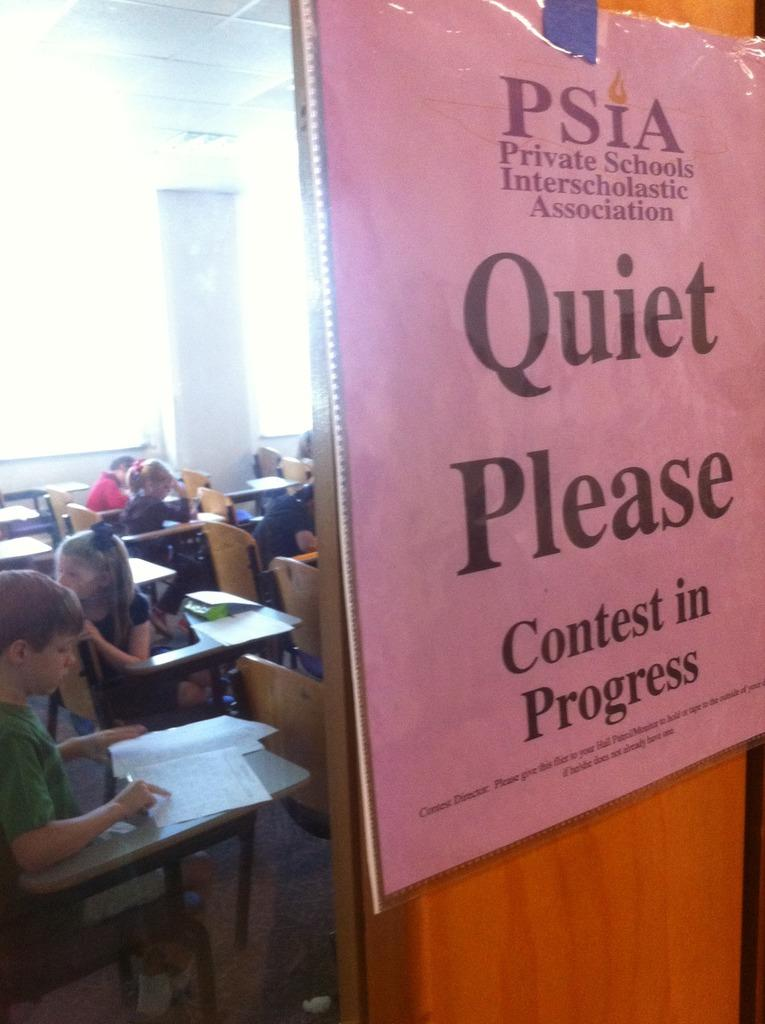<image>
Share a concise interpretation of the image provided. Several children are in a classroom with a closed door that has a pink piece of paper on it requesting silence due to a contest underway. 